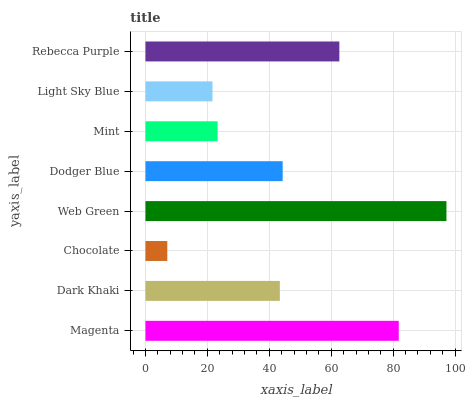Is Chocolate the minimum?
Answer yes or no. Yes. Is Web Green the maximum?
Answer yes or no. Yes. Is Dark Khaki the minimum?
Answer yes or no. No. Is Dark Khaki the maximum?
Answer yes or no. No. Is Magenta greater than Dark Khaki?
Answer yes or no. Yes. Is Dark Khaki less than Magenta?
Answer yes or no. Yes. Is Dark Khaki greater than Magenta?
Answer yes or no. No. Is Magenta less than Dark Khaki?
Answer yes or no. No. Is Dodger Blue the high median?
Answer yes or no. Yes. Is Dark Khaki the low median?
Answer yes or no. Yes. Is Chocolate the high median?
Answer yes or no. No. Is Mint the low median?
Answer yes or no. No. 